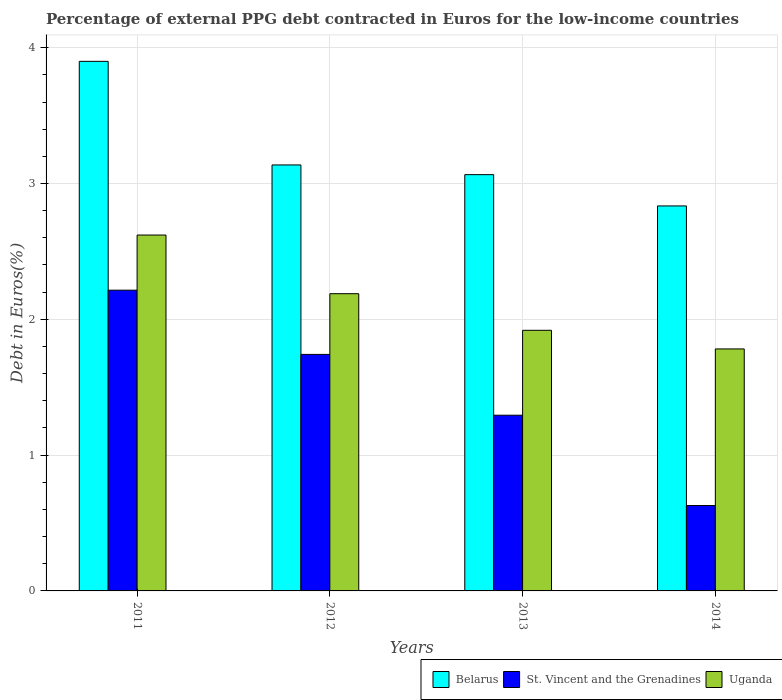How many different coloured bars are there?
Keep it short and to the point. 3. How many groups of bars are there?
Your answer should be very brief. 4. Are the number of bars per tick equal to the number of legend labels?
Ensure brevity in your answer.  Yes. Are the number of bars on each tick of the X-axis equal?
Offer a very short reply. Yes. What is the percentage of external PPG debt contracted in Euros in Belarus in 2014?
Offer a very short reply. 2.83. Across all years, what is the maximum percentage of external PPG debt contracted in Euros in St. Vincent and the Grenadines?
Provide a short and direct response. 2.21. Across all years, what is the minimum percentage of external PPG debt contracted in Euros in St. Vincent and the Grenadines?
Provide a short and direct response. 0.63. In which year was the percentage of external PPG debt contracted in Euros in St. Vincent and the Grenadines maximum?
Ensure brevity in your answer.  2011. In which year was the percentage of external PPG debt contracted in Euros in Belarus minimum?
Your answer should be very brief. 2014. What is the total percentage of external PPG debt contracted in Euros in Belarus in the graph?
Provide a short and direct response. 12.94. What is the difference between the percentage of external PPG debt contracted in Euros in Uganda in 2011 and that in 2014?
Make the answer very short. 0.84. What is the difference between the percentage of external PPG debt contracted in Euros in St. Vincent and the Grenadines in 2011 and the percentage of external PPG debt contracted in Euros in Uganda in 2013?
Your answer should be very brief. 0.3. What is the average percentage of external PPG debt contracted in Euros in Belarus per year?
Provide a short and direct response. 3.23. In the year 2011, what is the difference between the percentage of external PPG debt contracted in Euros in Uganda and percentage of external PPG debt contracted in Euros in St. Vincent and the Grenadines?
Offer a very short reply. 0.41. In how many years, is the percentage of external PPG debt contracted in Euros in Belarus greater than 2.6 %?
Give a very brief answer. 4. What is the ratio of the percentage of external PPG debt contracted in Euros in Uganda in 2012 to that in 2013?
Offer a very short reply. 1.14. What is the difference between the highest and the second highest percentage of external PPG debt contracted in Euros in St. Vincent and the Grenadines?
Give a very brief answer. 0.47. What is the difference between the highest and the lowest percentage of external PPG debt contracted in Euros in Belarus?
Offer a terse response. 1.06. In how many years, is the percentage of external PPG debt contracted in Euros in St. Vincent and the Grenadines greater than the average percentage of external PPG debt contracted in Euros in St. Vincent and the Grenadines taken over all years?
Provide a succinct answer. 2. What does the 3rd bar from the left in 2013 represents?
Keep it short and to the point. Uganda. What does the 2nd bar from the right in 2014 represents?
Provide a succinct answer. St. Vincent and the Grenadines. How many bars are there?
Provide a short and direct response. 12. How many years are there in the graph?
Your answer should be compact. 4. Does the graph contain any zero values?
Give a very brief answer. No. Where does the legend appear in the graph?
Provide a short and direct response. Bottom right. How are the legend labels stacked?
Keep it short and to the point. Horizontal. What is the title of the graph?
Your answer should be compact. Percentage of external PPG debt contracted in Euros for the low-income countries. What is the label or title of the Y-axis?
Make the answer very short. Debt in Euros(%). What is the Debt in Euros(%) of Belarus in 2011?
Your answer should be compact. 3.9. What is the Debt in Euros(%) of St. Vincent and the Grenadines in 2011?
Offer a very short reply. 2.21. What is the Debt in Euros(%) in Uganda in 2011?
Your answer should be compact. 2.62. What is the Debt in Euros(%) of Belarus in 2012?
Give a very brief answer. 3.14. What is the Debt in Euros(%) of St. Vincent and the Grenadines in 2012?
Your response must be concise. 1.74. What is the Debt in Euros(%) in Uganda in 2012?
Your response must be concise. 2.19. What is the Debt in Euros(%) of Belarus in 2013?
Ensure brevity in your answer.  3.07. What is the Debt in Euros(%) in St. Vincent and the Grenadines in 2013?
Keep it short and to the point. 1.29. What is the Debt in Euros(%) of Uganda in 2013?
Provide a short and direct response. 1.92. What is the Debt in Euros(%) of Belarus in 2014?
Keep it short and to the point. 2.83. What is the Debt in Euros(%) in St. Vincent and the Grenadines in 2014?
Provide a succinct answer. 0.63. What is the Debt in Euros(%) of Uganda in 2014?
Keep it short and to the point. 1.78. Across all years, what is the maximum Debt in Euros(%) in Belarus?
Your answer should be compact. 3.9. Across all years, what is the maximum Debt in Euros(%) in St. Vincent and the Grenadines?
Provide a succinct answer. 2.21. Across all years, what is the maximum Debt in Euros(%) of Uganda?
Give a very brief answer. 2.62. Across all years, what is the minimum Debt in Euros(%) in Belarus?
Keep it short and to the point. 2.83. Across all years, what is the minimum Debt in Euros(%) of St. Vincent and the Grenadines?
Make the answer very short. 0.63. Across all years, what is the minimum Debt in Euros(%) in Uganda?
Give a very brief answer. 1.78. What is the total Debt in Euros(%) of Belarus in the graph?
Provide a succinct answer. 12.94. What is the total Debt in Euros(%) in St. Vincent and the Grenadines in the graph?
Offer a terse response. 5.88. What is the total Debt in Euros(%) of Uganda in the graph?
Offer a terse response. 8.51. What is the difference between the Debt in Euros(%) of Belarus in 2011 and that in 2012?
Your answer should be very brief. 0.76. What is the difference between the Debt in Euros(%) of St. Vincent and the Grenadines in 2011 and that in 2012?
Ensure brevity in your answer.  0.47. What is the difference between the Debt in Euros(%) in Uganda in 2011 and that in 2012?
Offer a very short reply. 0.43. What is the difference between the Debt in Euros(%) of Belarus in 2011 and that in 2013?
Your answer should be compact. 0.83. What is the difference between the Debt in Euros(%) of St. Vincent and the Grenadines in 2011 and that in 2013?
Ensure brevity in your answer.  0.92. What is the difference between the Debt in Euros(%) in Uganda in 2011 and that in 2013?
Your answer should be compact. 0.7. What is the difference between the Debt in Euros(%) of Belarus in 2011 and that in 2014?
Your answer should be compact. 1.06. What is the difference between the Debt in Euros(%) in St. Vincent and the Grenadines in 2011 and that in 2014?
Your answer should be very brief. 1.59. What is the difference between the Debt in Euros(%) in Uganda in 2011 and that in 2014?
Make the answer very short. 0.84. What is the difference between the Debt in Euros(%) of Belarus in 2012 and that in 2013?
Ensure brevity in your answer.  0.07. What is the difference between the Debt in Euros(%) in St. Vincent and the Grenadines in 2012 and that in 2013?
Provide a succinct answer. 0.45. What is the difference between the Debt in Euros(%) in Uganda in 2012 and that in 2013?
Keep it short and to the point. 0.27. What is the difference between the Debt in Euros(%) of Belarus in 2012 and that in 2014?
Your response must be concise. 0.3. What is the difference between the Debt in Euros(%) of St. Vincent and the Grenadines in 2012 and that in 2014?
Make the answer very short. 1.11. What is the difference between the Debt in Euros(%) in Uganda in 2012 and that in 2014?
Offer a terse response. 0.41. What is the difference between the Debt in Euros(%) of Belarus in 2013 and that in 2014?
Offer a terse response. 0.23. What is the difference between the Debt in Euros(%) of St. Vincent and the Grenadines in 2013 and that in 2014?
Offer a terse response. 0.67. What is the difference between the Debt in Euros(%) of Uganda in 2013 and that in 2014?
Ensure brevity in your answer.  0.14. What is the difference between the Debt in Euros(%) in Belarus in 2011 and the Debt in Euros(%) in St. Vincent and the Grenadines in 2012?
Offer a very short reply. 2.16. What is the difference between the Debt in Euros(%) in Belarus in 2011 and the Debt in Euros(%) in Uganda in 2012?
Your response must be concise. 1.71. What is the difference between the Debt in Euros(%) of St. Vincent and the Grenadines in 2011 and the Debt in Euros(%) of Uganda in 2012?
Your answer should be very brief. 0.03. What is the difference between the Debt in Euros(%) of Belarus in 2011 and the Debt in Euros(%) of St. Vincent and the Grenadines in 2013?
Your response must be concise. 2.61. What is the difference between the Debt in Euros(%) in Belarus in 2011 and the Debt in Euros(%) in Uganda in 2013?
Your answer should be compact. 1.98. What is the difference between the Debt in Euros(%) in St. Vincent and the Grenadines in 2011 and the Debt in Euros(%) in Uganda in 2013?
Offer a very short reply. 0.3. What is the difference between the Debt in Euros(%) in Belarus in 2011 and the Debt in Euros(%) in St. Vincent and the Grenadines in 2014?
Your answer should be very brief. 3.27. What is the difference between the Debt in Euros(%) of Belarus in 2011 and the Debt in Euros(%) of Uganda in 2014?
Give a very brief answer. 2.12. What is the difference between the Debt in Euros(%) of St. Vincent and the Grenadines in 2011 and the Debt in Euros(%) of Uganda in 2014?
Your answer should be compact. 0.43. What is the difference between the Debt in Euros(%) in Belarus in 2012 and the Debt in Euros(%) in St. Vincent and the Grenadines in 2013?
Your response must be concise. 1.84. What is the difference between the Debt in Euros(%) of Belarus in 2012 and the Debt in Euros(%) of Uganda in 2013?
Keep it short and to the point. 1.22. What is the difference between the Debt in Euros(%) in St. Vincent and the Grenadines in 2012 and the Debt in Euros(%) in Uganda in 2013?
Your response must be concise. -0.18. What is the difference between the Debt in Euros(%) in Belarus in 2012 and the Debt in Euros(%) in St. Vincent and the Grenadines in 2014?
Give a very brief answer. 2.51. What is the difference between the Debt in Euros(%) of Belarus in 2012 and the Debt in Euros(%) of Uganda in 2014?
Keep it short and to the point. 1.35. What is the difference between the Debt in Euros(%) in St. Vincent and the Grenadines in 2012 and the Debt in Euros(%) in Uganda in 2014?
Give a very brief answer. -0.04. What is the difference between the Debt in Euros(%) of Belarus in 2013 and the Debt in Euros(%) of St. Vincent and the Grenadines in 2014?
Offer a very short reply. 2.44. What is the difference between the Debt in Euros(%) in Belarus in 2013 and the Debt in Euros(%) in Uganda in 2014?
Give a very brief answer. 1.28. What is the difference between the Debt in Euros(%) in St. Vincent and the Grenadines in 2013 and the Debt in Euros(%) in Uganda in 2014?
Your response must be concise. -0.49. What is the average Debt in Euros(%) of Belarus per year?
Offer a very short reply. 3.23. What is the average Debt in Euros(%) of St. Vincent and the Grenadines per year?
Make the answer very short. 1.47. What is the average Debt in Euros(%) in Uganda per year?
Offer a terse response. 2.13. In the year 2011, what is the difference between the Debt in Euros(%) of Belarus and Debt in Euros(%) of St. Vincent and the Grenadines?
Ensure brevity in your answer.  1.69. In the year 2011, what is the difference between the Debt in Euros(%) in Belarus and Debt in Euros(%) in Uganda?
Ensure brevity in your answer.  1.28. In the year 2011, what is the difference between the Debt in Euros(%) of St. Vincent and the Grenadines and Debt in Euros(%) of Uganda?
Give a very brief answer. -0.41. In the year 2012, what is the difference between the Debt in Euros(%) in Belarus and Debt in Euros(%) in St. Vincent and the Grenadines?
Keep it short and to the point. 1.4. In the year 2012, what is the difference between the Debt in Euros(%) in Belarus and Debt in Euros(%) in Uganda?
Make the answer very short. 0.95. In the year 2012, what is the difference between the Debt in Euros(%) in St. Vincent and the Grenadines and Debt in Euros(%) in Uganda?
Ensure brevity in your answer.  -0.45. In the year 2013, what is the difference between the Debt in Euros(%) in Belarus and Debt in Euros(%) in St. Vincent and the Grenadines?
Offer a terse response. 1.77. In the year 2013, what is the difference between the Debt in Euros(%) of Belarus and Debt in Euros(%) of Uganda?
Ensure brevity in your answer.  1.15. In the year 2013, what is the difference between the Debt in Euros(%) in St. Vincent and the Grenadines and Debt in Euros(%) in Uganda?
Give a very brief answer. -0.63. In the year 2014, what is the difference between the Debt in Euros(%) in Belarus and Debt in Euros(%) in St. Vincent and the Grenadines?
Your response must be concise. 2.21. In the year 2014, what is the difference between the Debt in Euros(%) in Belarus and Debt in Euros(%) in Uganda?
Provide a succinct answer. 1.05. In the year 2014, what is the difference between the Debt in Euros(%) in St. Vincent and the Grenadines and Debt in Euros(%) in Uganda?
Give a very brief answer. -1.15. What is the ratio of the Debt in Euros(%) in Belarus in 2011 to that in 2012?
Provide a succinct answer. 1.24. What is the ratio of the Debt in Euros(%) in St. Vincent and the Grenadines in 2011 to that in 2012?
Offer a very short reply. 1.27. What is the ratio of the Debt in Euros(%) of Uganda in 2011 to that in 2012?
Provide a short and direct response. 1.2. What is the ratio of the Debt in Euros(%) of Belarus in 2011 to that in 2013?
Your answer should be very brief. 1.27. What is the ratio of the Debt in Euros(%) of St. Vincent and the Grenadines in 2011 to that in 2013?
Offer a very short reply. 1.71. What is the ratio of the Debt in Euros(%) in Uganda in 2011 to that in 2013?
Your answer should be very brief. 1.37. What is the ratio of the Debt in Euros(%) in Belarus in 2011 to that in 2014?
Provide a short and direct response. 1.38. What is the ratio of the Debt in Euros(%) in St. Vincent and the Grenadines in 2011 to that in 2014?
Keep it short and to the point. 3.52. What is the ratio of the Debt in Euros(%) of Uganda in 2011 to that in 2014?
Offer a very short reply. 1.47. What is the ratio of the Debt in Euros(%) in Belarus in 2012 to that in 2013?
Your answer should be compact. 1.02. What is the ratio of the Debt in Euros(%) of St. Vincent and the Grenadines in 2012 to that in 2013?
Offer a terse response. 1.35. What is the ratio of the Debt in Euros(%) of Uganda in 2012 to that in 2013?
Your answer should be compact. 1.14. What is the ratio of the Debt in Euros(%) of Belarus in 2012 to that in 2014?
Give a very brief answer. 1.11. What is the ratio of the Debt in Euros(%) in St. Vincent and the Grenadines in 2012 to that in 2014?
Give a very brief answer. 2.77. What is the ratio of the Debt in Euros(%) of Uganda in 2012 to that in 2014?
Keep it short and to the point. 1.23. What is the ratio of the Debt in Euros(%) in Belarus in 2013 to that in 2014?
Give a very brief answer. 1.08. What is the ratio of the Debt in Euros(%) of St. Vincent and the Grenadines in 2013 to that in 2014?
Keep it short and to the point. 2.06. What is the ratio of the Debt in Euros(%) in Uganda in 2013 to that in 2014?
Your answer should be compact. 1.08. What is the difference between the highest and the second highest Debt in Euros(%) in Belarus?
Offer a terse response. 0.76. What is the difference between the highest and the second highest Debt in Euros(%) of St. Vincent and the Grenadines?
Offer a very short reply. 0.47. What is the difference between the highest and the second highest Debt in Euros(%) of Uganda?
Offer a very short reply. 0.43. What is the difference between the highest and the lowest Debt in Euros(%) of Belarus?
Provide a short and direct response. 1.06. What is the difference between the highest and the lowest Debt in Euros(%) of St. Vincent and the Grenadines?
Your answer should be very brief. 1.59. What is the difference between the highest and the lowest Debt in Euros(%) of Uganda?
Keep it short and to the point. 0.84. 